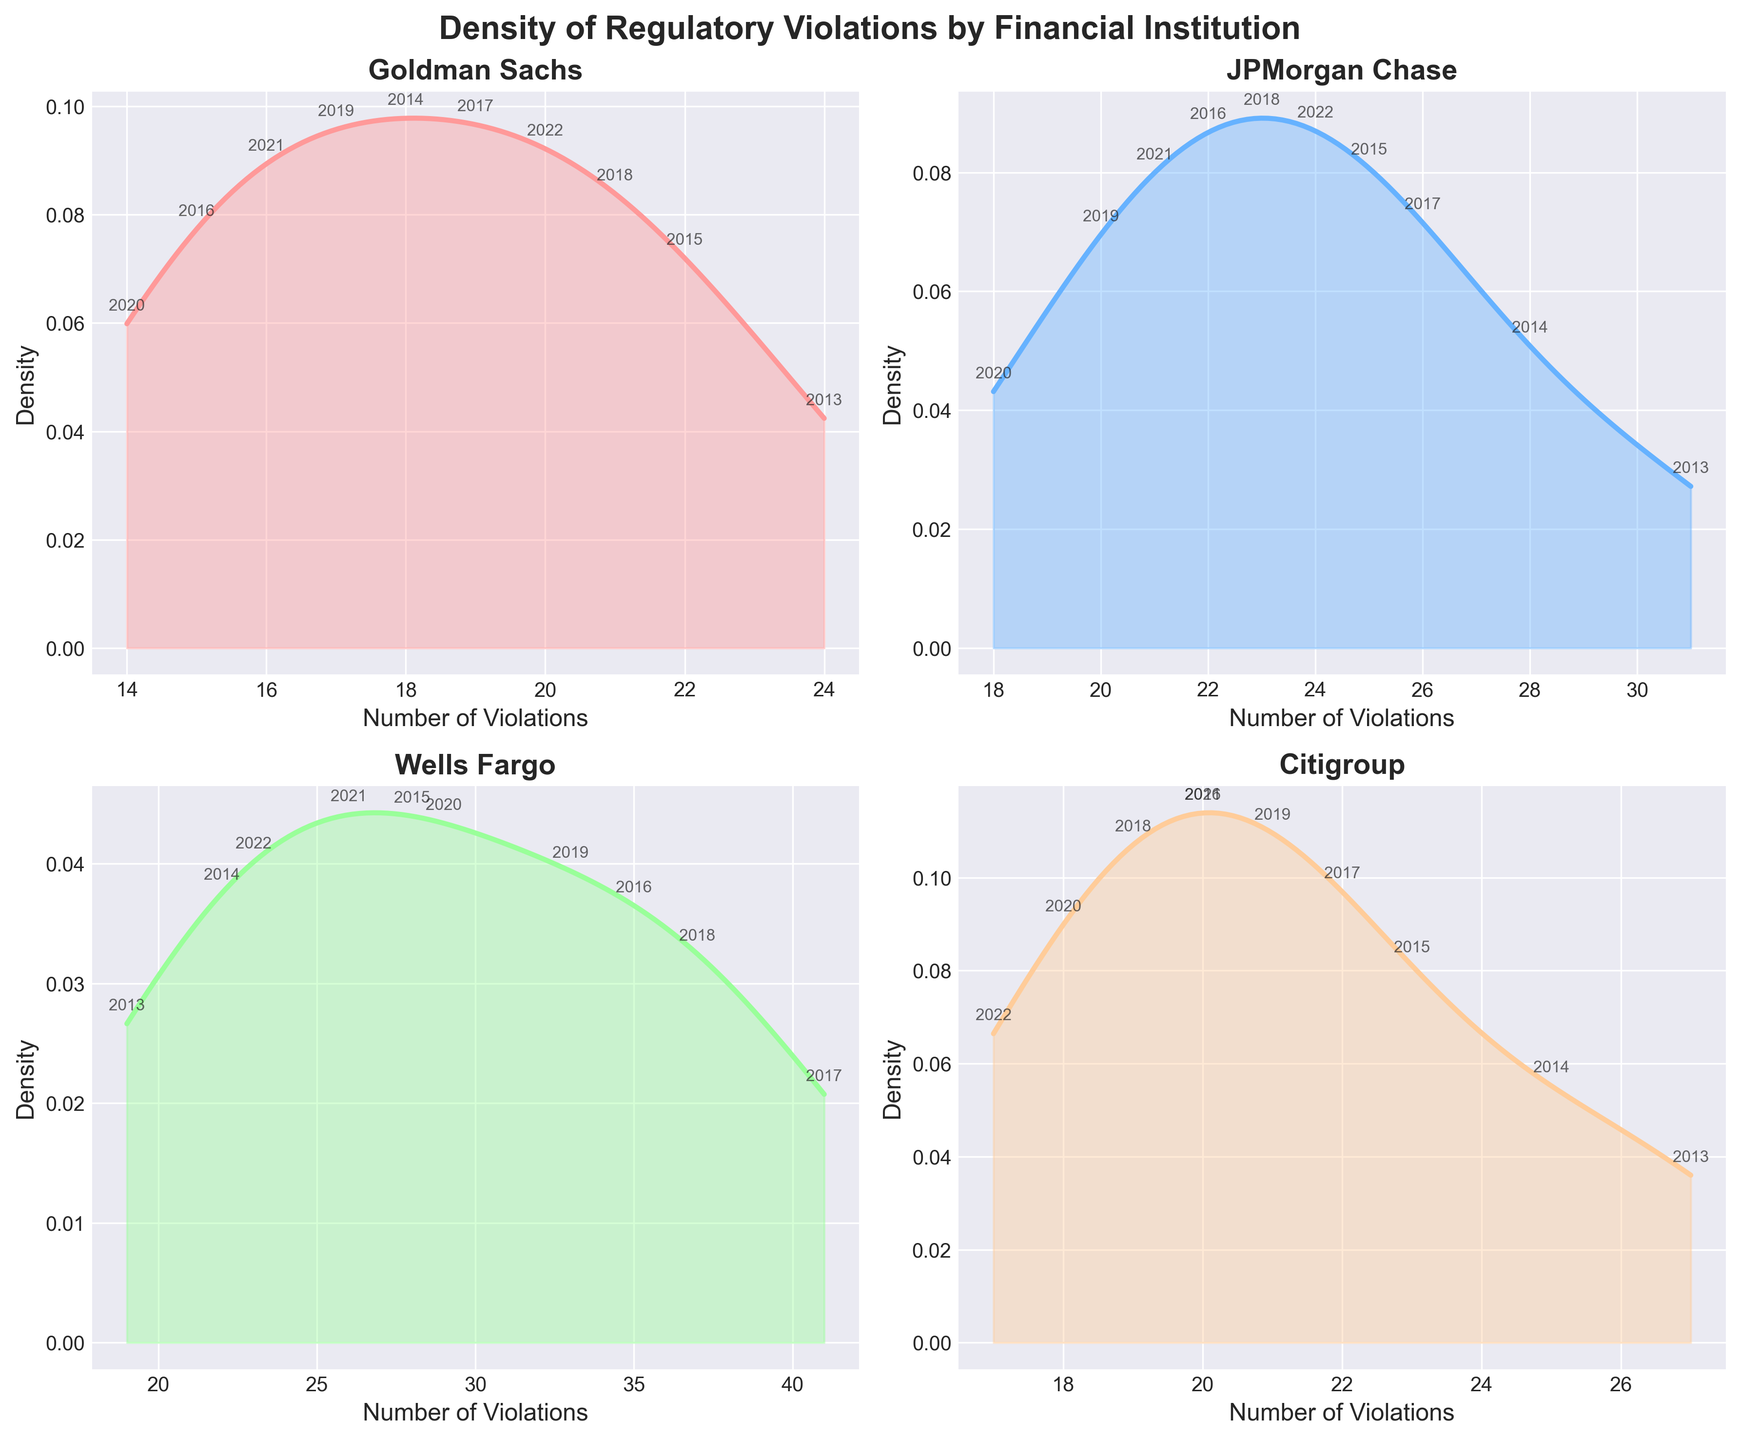What's the title of the overall figure? The title is located at the top of the figure, and it reads "Density of Regulatory Violations by Financial Institution".
Answer: Density of Regulatory Violations by Financial Institution What does the x-axis represent for each subplot? The x-axis in each subplot is labeled "Number of Violations," indicating it represents the number of regulatory violations.
Answer: Number of Violations Which institution has the highest peak density for regulatory violations? By looking at the density peaks in the subplots, Wells Fargo has the highest peak density value compared to the other institutions.
Answer: Wells Fargo How does the density of violations around 20 compare between Goldman Sachs and Citigroup? In the Goldman Sachs subplot, the density around 20 is higher than in the Citigroup subplot, where the density around 20 is noticeably lower.
Answer: Higher in Goldman Sachs Which year is annotated closest to the highest density peak for JPMorgan Chase? In the JPMorgan Chase subplot, the year annotated closest to the highest density peak is 2013.
Answer: 2013 What trend do we see in Wells Fargo's violations from 2013 to 2022? By observing the annotated years along the density plot of Wells Fargo, we see that violations increased from 2013, peaked around 2017, and then generally decreased toward 2022.
Answer: Increased then decreased Which two institutions show a clear decrease in the number of violations toward more recent years? Both Goldman Sachs and JPMorgan Chase show a clear decrease in the number of violations toward more recent years in their density plots.
Answer: Goldman Sachs and JPMorgan Chase What is the relative height of the peak density between Citigroup and Goldman Sachs? Comparing the peak heights of the density curves in the subplots, it is evident that Goldman Sachs has a higher peak density than Citigroup.
Answer: Higher in Goldman Sachs At which value(s) do the subplots for Wells Fargo and Citigroup intersect along the x-axis? By observing the x-axis and density curves, both Wells Fargo and Citigroup intersect around the number of violations near 23.
Answer: Around 23 How do the variations in violation counts for JPMorgan Chase and Wells Fargo differ? The subplot for JPMorgan Chase shows a narrower, more central distribution, whereas Wells Fargo has a wider distribution with more peaks across a broader range of violations.
Answer: JPMorgan Chase is narrower; Wells Fargo is wider 